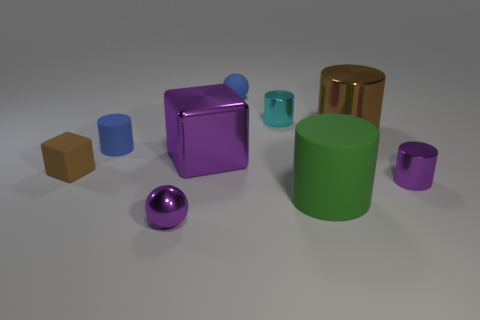What color is the rubber cylinder that is in front of the large purple block?
Keep it short and to the point. Green. What number of large cylinders are the same color as the rubber sphere?
Your answer should be very brief. 0. Are there fewer blue rubber balls that are to the right of the purple shiny block than matte cylinders that are behind the brown matte block?
Make the answer very short. No. There is a big green cylinder; how many objects are behind it?
Your response must be concise. 7. Is there a small brown cylinder made of the same material as the tiny cube?
Your answer should be compact. No. Are there more tiny brown blocks in front of the brown rubber block than brown shiny cylinders that are left of the purple cube?
Provide a short and direct response. No. How big is the purple cylinder?
Offer a terse response. Small. The tiny purple shiny object that is to the left of the big purple metal object has what shape?
Offer a very short reply. Sphere. Is the shape of the small brown rubber object the same as the large brown object?
Make the answer very short. No. Are there the same number of tiny purple spheres to the right of the green object and large green rubber things?
Your answer should be compact. No. 